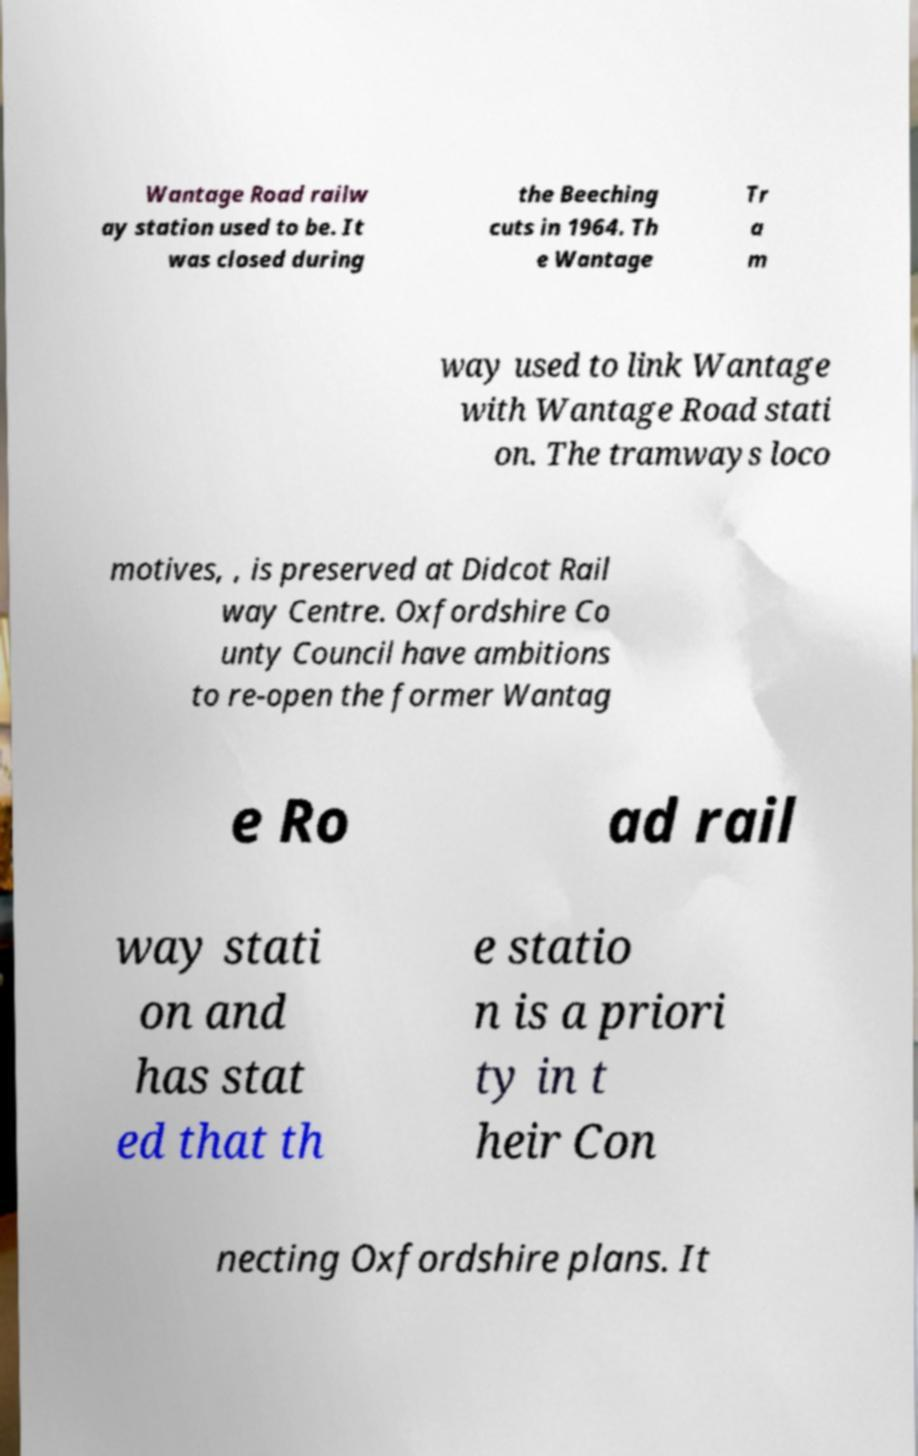Can you accurately transcribe the text from the provided image for me? Wantage Road railw ay station used to be. It was closed during the Beeching cuts in 1964. Th e Wantage Tr a m way used to link Wantage with Wantage Road stati on. The tramways loco motives, , is preserved at Didcot Rail way Centre. Oxfordshire Co unty Council have ambitions to re-open the former Wantag e Ro ad rail way stati on and has stat ed that th e statio n is a priori ty in t heir Con necting Oxfordshire plans. It 